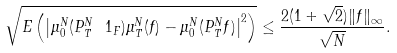Convert formula to latex. <formula><loc_0><loc_0><loc_500><loc_500>\sqrt { E \left ( \left | \mu ^ { N } _ { 0 } ( P ^ { N } _ { T } \ 1 _ { F } ) \mu ^ { N } _ { T } ( f ) - \mu ^ { N } _ { 0 } ( P ^ { N } _ { T } f ) \right | ^ { 2 } \right ) } \leq \frac { 2 ( 1 + \sqrt { 2 } ) \| f \| _ { \infty } } { \sqrt { N } } .</formula> 